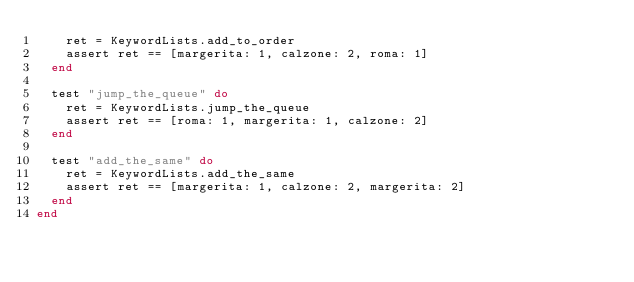Convert code to text. <code><loc_0><loc_0><loc_500><loc_500><_Elixir_>    ret = KeywordLists.add_to_order
    assert ret == [margerita: 1, calzone: 2, roma: 1]
  end

  test "jump_the_queue" do
    ret = KeywordLists.jump_the_queue
    assert ret == [roma: 1, margerita: 1, calzone: 2]
  end

  test "add_the_same" do
    ret = KeywordLists.add_the_same
    assert ret == [margerita: 1, calzone: 2, margerita: 2]
  end
end
</code> 